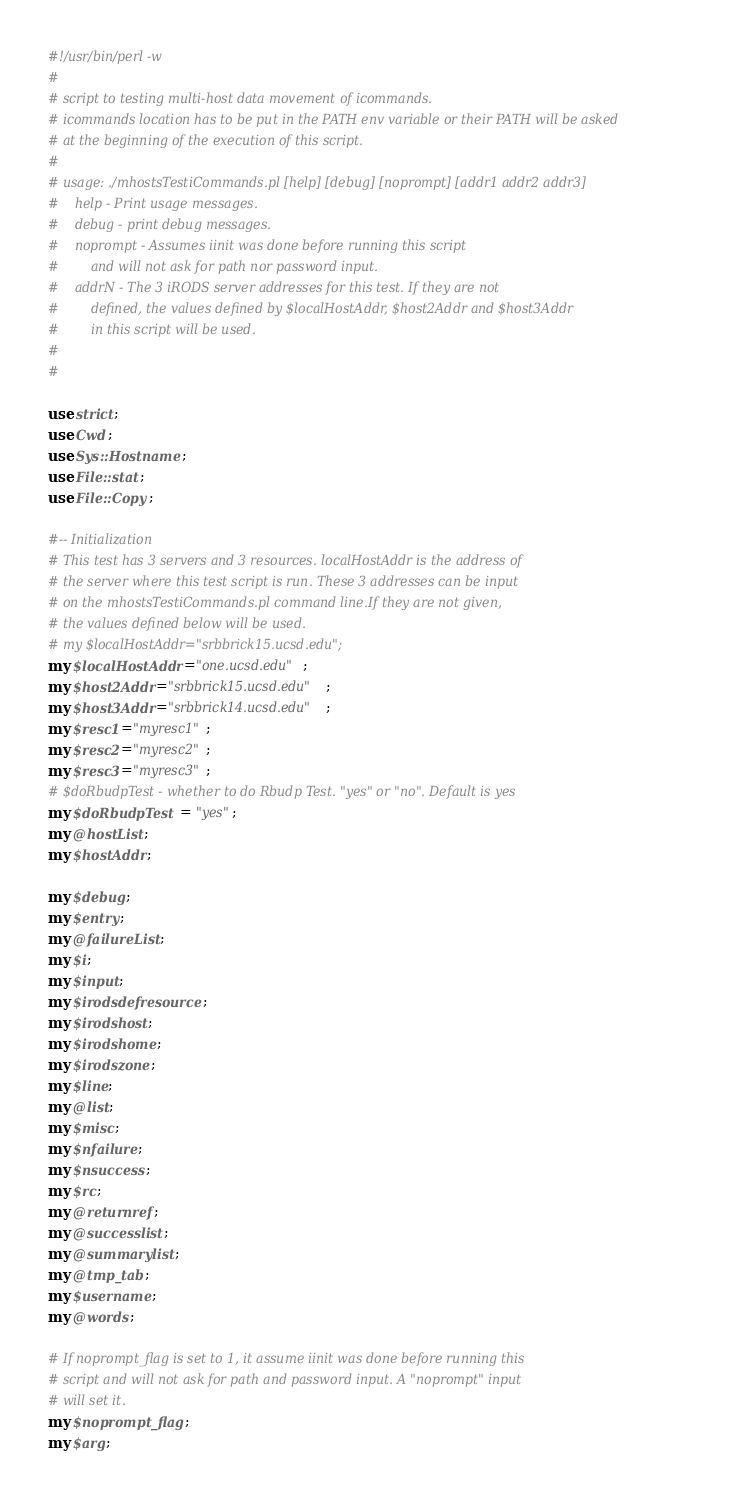Convert code to text. <code><loc_0><loc_0><loc_500><loc_500><_Perl_>#!/usr/bin/perl -w
#
# script to testing multi-host data movement of icommands.
# icommands location has to be put in the PATH env variable or their PATH will be asked
# at the beginning of the execution of this script.
#
# usage: ./mhostsTestiCommands.pl [help] [debug] [noprompt] [addr1 addr2 addr3]
#    help - Print usage messages.
#    debug - print debug messages.
#    noprompt - Assumes iinit was done before running this script 
#        and will not ask for path nor password input.
#    addrN - The 3 iRODS server addresses for this test. If they are not
#        defined, the values defined by $localHostAddr, $host2Addr and $host3Addr
#        in this script will be used.
# 
#

use strict;
use Cwd;
use Sys::Hostname;
use File::stat;
use File::Copy;

#-- Initialization
# This test has 3 servers and 3 resources. localHostAddr is the address of
# the server where this test script is run. These 3 addresses can be input 
# on the mhostsTestiCommands.pl command line.If they are not given, 
# the values defined below will be used.
# my $localHostAddr="srbbrick15.ucsd.edu";
my $localHostAddr="one.ucsd.edu";
my $host2Addr="srbbrick15.ucsd.edu";
my $host3Addr="srbbrick14.ucsd.edu";
my $resc1="myresc1";
my $resc2="myresc2";
my $resc3="myresc3";
# $doRbudpTest - whether to do Rbudp Test. "yes" or "no". Default is yes
my $doRbudpTest = "yes";
my @hostList;
my $hostAddr;

my $debug;
my $entry;
my @failureList;
my $i;
my $input;
my $irodsdefresource;
my $irodshost;
my $irodshome;
my $irodszone;
my $line;
my @list;
my $misc;
my $nfailure;
my $nsuccess;
my $rc;
my @returnref;
my @successlist;
my @summarylist;
my @tmp_tab;
my $username;
my @words;

# If noprompt_flag is set to 1, it assume iinit was done before running this
# script and will not ask for path and password input. A "noprompt" input 
# will set it.
my $noprompt_flag;
my $arg;</code> 